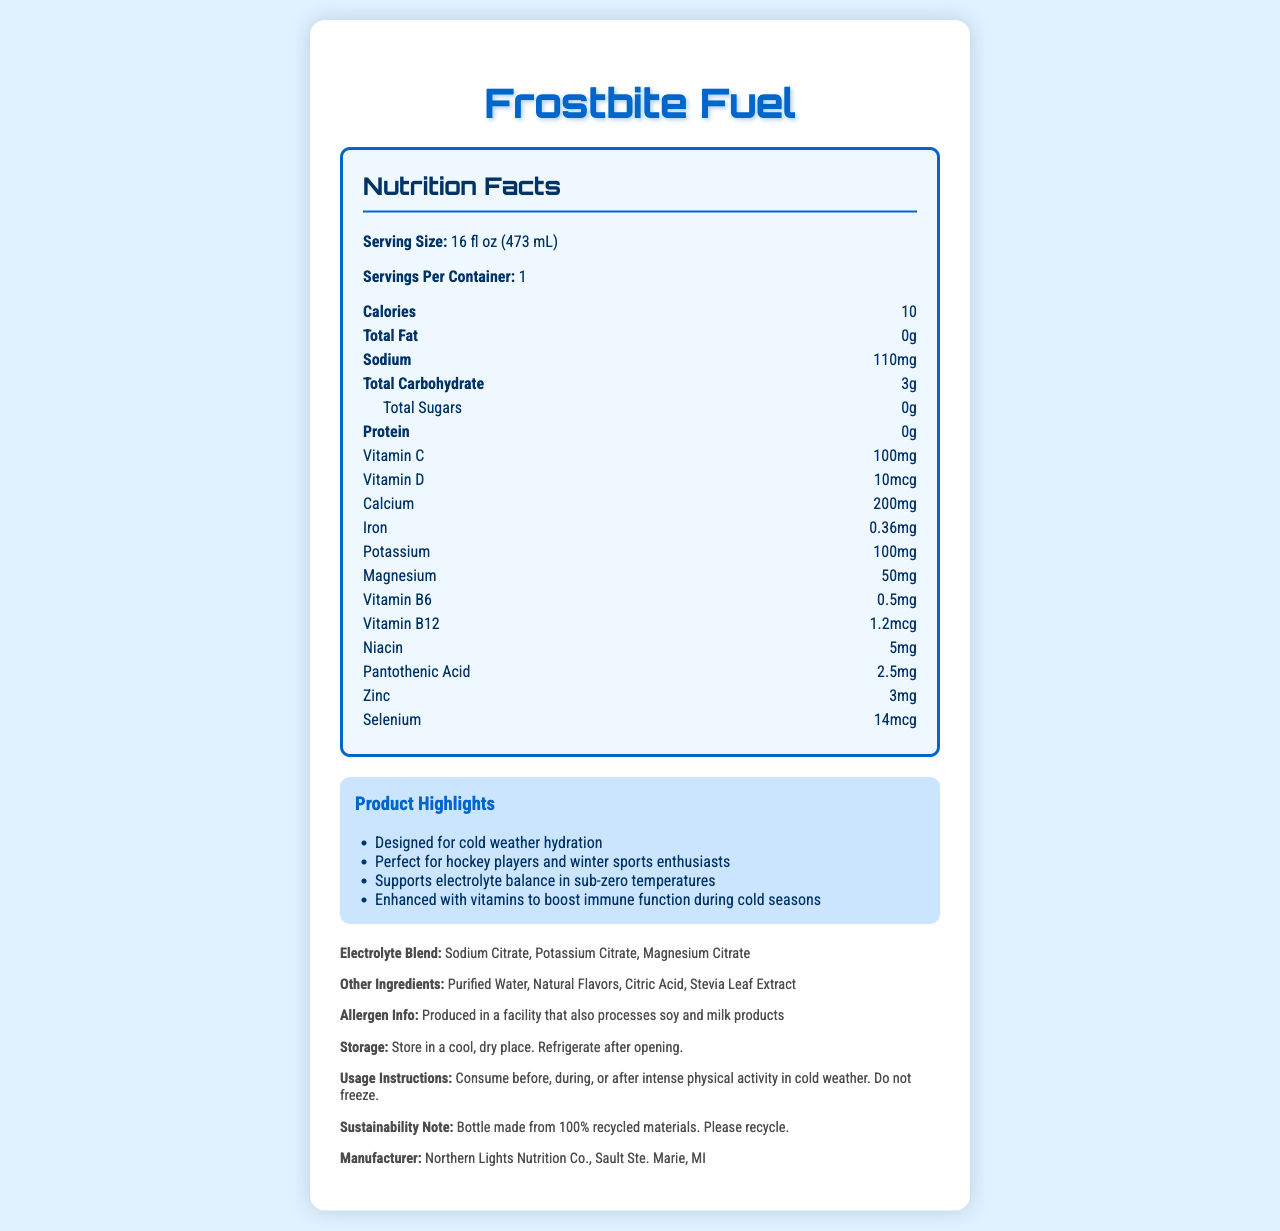what is the product name of the vitamin-fortified water? The product name of the vitamin-fortified water is "Frostbite Fuel", as stated at the top of the document and within the title.
Answer: Frostbite Fuel how many calories are in a serving of Frostbite Fuel? The document specifies that there are 10 calories per serving of Frostbite Fuel.
Answer: 10 what is the serving size of Frostbite Fuel? The serving size is mentioned as "16 fl oz (473 mL)" under the Nutrition Facts section.
Answer: 16 fl oz (473 mL) how much sodium does one serving contain? According to the Nutrition Facts, one serving contains 110mg of sodium.
Answer: 110mg which vitamins are included in Frostbite Fuel, and in what amounts? The document lists the amounts of various vitamins under the Nutrition Facts section.
Answer: Vitamin C (100mg), Vitamin D (10mcg), Vitamin B6 (0.5mg), Vitamin B12 (1.2mcg), Niacin (5mg), Pantothenic Acid (2.5mg) what are the other ingredients listed in Frostbite Fuel? The other ingredients are mentioned in the "Additional Info" section of the document.
Answer: Purified Water, Natural Flavors, Citric Acid, Stevia Leaf Extract what should be done with the bottle after consumption according to the sustainability note? The document states, "Bottle made from 100% recycled materials. Please recycle."
Answer: recycle what should you do with Frostbite Fuel after opening it? The storage information in the document indicates that the product should be refrigerated after opening.
Answer: Refrigerate what is the manufacturer of Frostbite Fuel? The manufacturer is listed in the "Additional Info" section.
Answer: Northern Lights Nutrition Co., Sault Ste. Marie, MI what are the main benefits of Frostbite Fuel according to the marketing claims? (select all that apply): A. supports weight loss B. designed for cold weather hydration C. enhances muscle growth D. supports electrolyte balance in sub-zero temperatures The marketing claims highlighted are that it is "Designed for cold weather hydration" and "Supports electrolyte balance in sub-zero temperatures."
Answer: B, D which of the following is part of the electrolyte blend in Frostbite Fuel? A. Sodium Chloride B. Magnesium Citrate C. Calcium Carbonate D. Potassium Phosphate According to the document, the electrolyte blend includes Sodium Citrate, Potassium Citrate, and Magnesium Citrate.
Answer: B is Frostbite Fuel suitable for people with soy allergies? The document warns that it is "Produced in a facility that also processes soy and milk products," implying a risk of cross-contamination.
Answer: No summarize the main idea of the Frostbite Fuel document. The document provides comprehensive details about Frostbite Fuel's nutritional content, benefits for cold weather, ingredients, manufacturer information, and usage instructions, emphasizing its design for hydration in cold climates.
Answer: Frostbite Fuel is a vitamin-fortified water designed for cold weather hydration, containing various vitamins and electrolytes essential for maintaining hydration and immune function during cold seasons. The product is manufactured by Northern Lights Nutrition Co. and is suitable for winter sports enthusiasts, including hockey players. It features specific serving sizes and nutritional values, with additional considerations for storage and sustainability. how much fiber does Frostbite Fuel contain? The document does not list fiber content under the total carbohydrate section or anywhere else.
Answer: Not enough information 